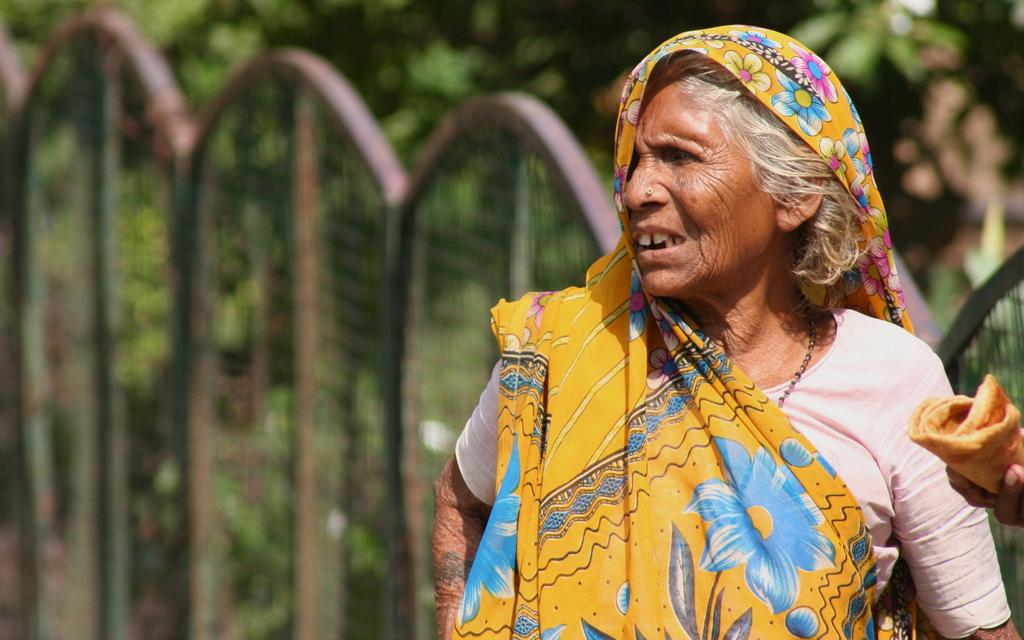Who is present on the right side of the image? There is a woman on the right side of the image. What is the woman holding in her fingers? There is an object in the fingers of a person, but we cannot determine if it is the woman or someone else. What can be seen in the background of the image? There is a fence and trees in the background of the image. What type of noise can be heard coming from the lunch in the image? There is no lunch present in the image, so it's not possible to determine what type of noise might be heard. 